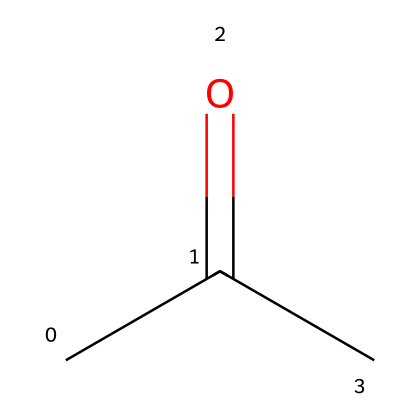What is the molecular formula of acetone? Acetone has three carbon atoms, six hydrogen atoms, and one oxygen atom in its structure, which gives the molecular formula C3H6O.
Answer: C3H6O How many carbon atoms are in acetone? In the SMILES representation, "CC(=O)C" shows three carbon atoms (two at the beginning and one connected to the carbonyl carbon).
Answer: 3 What type of functional group is present in acetone? The SMILES notation indicates a carbonyl group (C=O) is present, which is characteristic of ketones, thus making this chemical a ketone.
Answer: ketone How many hydrogen atoms are bonded to the carbonyl carbon? The acetone structure has no hydrogen atoms bonded to the carbonyl carbon (the carbon in C=O), as it is connected to an oxygen instead and has other carbon atoms attached.
Answer: 0 What is the total number of bonds in acetone? Analyzing the structure, acetone has a total of seven bonds: three C-C single bonds and one C=O double bond.
Answer: 7 Which part of the structure determines its volatility? The carbonyl group (C=O) contributes to the compound's volatility since the presence of this functional group allows for stronger intermolecular forces compared to simpler hydrocarbons.
Answer: carbonyl group What distinguishes acetone from aldehydes? Acetone contains a carbonyl group located between two carbon atoms, which is typical for ketones, while aldehydes have a carbonyl group at the end of the carbon chain.
Answer: position of carbonyl 